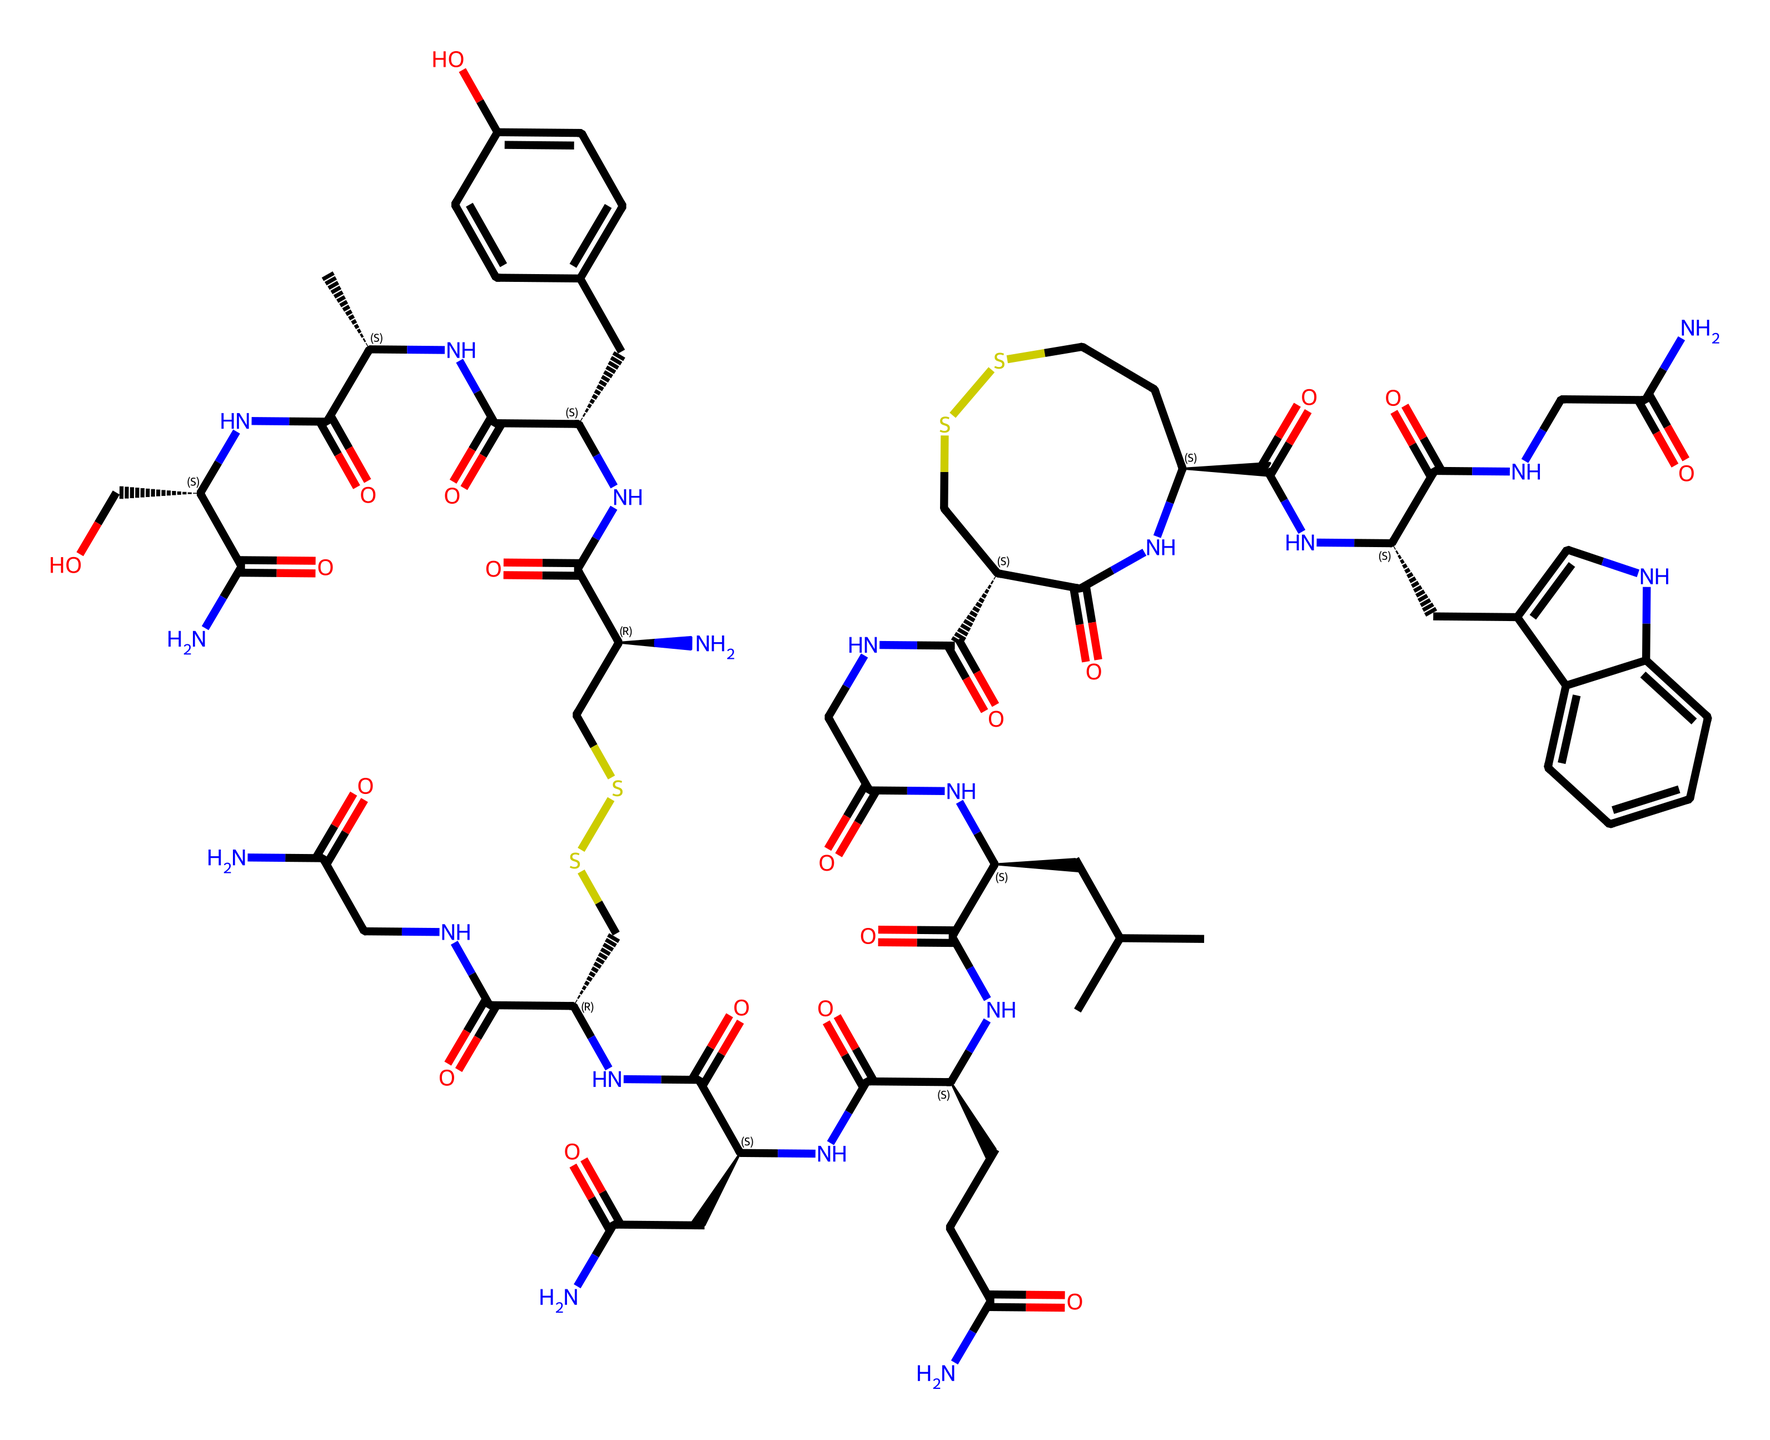What is the molecular formula of oxytocin based on the SMILES? The molecular formula is derived from counting the number of atoms from the SMILES. The breakdown shows that there are 43 carbons, 66 hydrogens, 12 nitrogens, and 6 oxygens, which results in the molecular formula C43H66N12O6.
Answer: C43H66N12O6 How many chiral centers are present in oxytocin? Chiral centers are indicated by symbols in the SMILES (like @ or @@) which tell us where chirality occurs. The SMILES indicates there are four chiral centers based on these symbols.
Answer: four What type of bonds are primarily found in the oxytocin structure? Analyzing the SMILES shows the presence of peptide bonds (C(=O)N) between amino acids, indicating it is primarily composed of covalent bonds.
Answer: peptide bonds What is the functional group introduced by the "N" in the structure? The presence of "N" in the SMILES indicates the presence of amine groups, which are characteristic of amino acids and are crucial for peptide bonds.
Answer: amine groups Are there any disulfide bonds in oxytocin? By identifying the "SS" in the SMILES, we can confirm that disulfide bonds are present, which contribute to the stability and conformation of the molecule.
Answer: disulfide bonds What is the significance of the aromatic ring in oxytocin? The aromatic ring indicated by "c" in the SMILES suggests that it is part of the structure that may play a role in binding interactions or stability, specifically in interactions with receptors.
Answer: binding interactions 